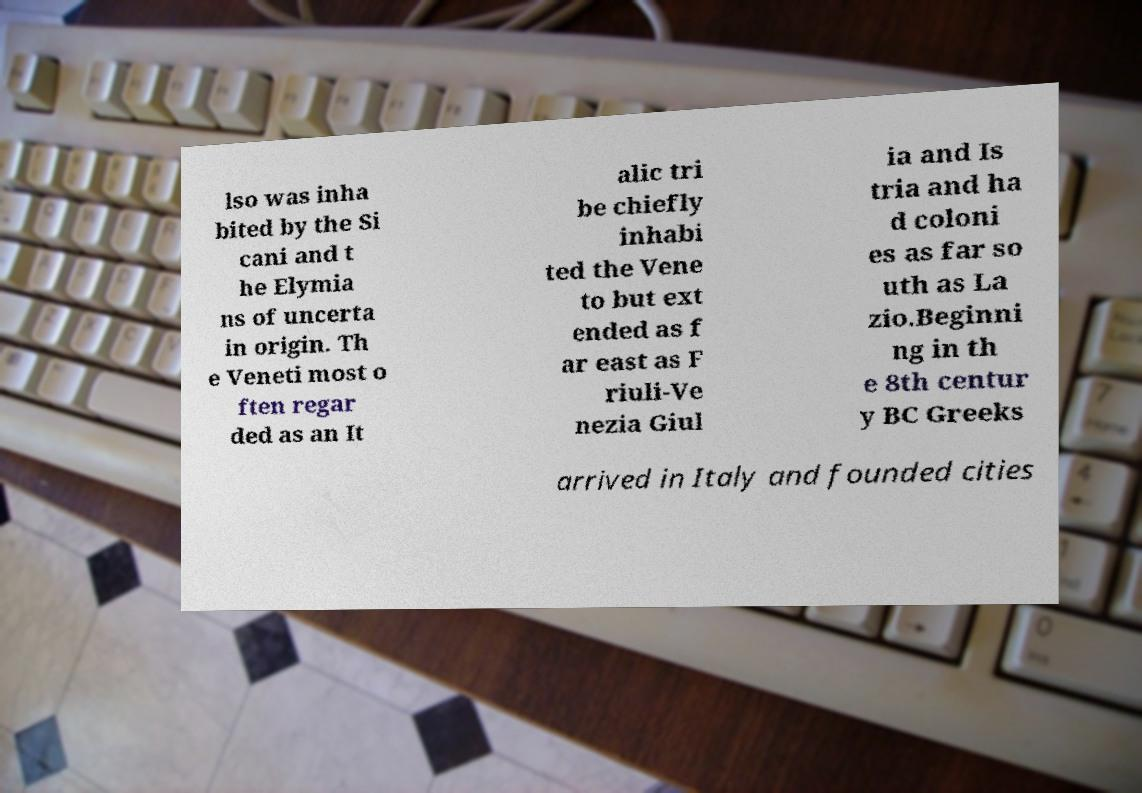Could you extract and type out the text from this image? lso was inha bited by the Si cani and t he Elymia ns of uncerta in origin. Th e Veneti most o ften regar ded as an It alic tri be chiefly inhabi ted the Vene to but ext ended as f ar east as F riuli-Ve nezia Giul ia and Is tria and ha d coloni es as far so uth as La zio.Beginni ng in th e 8th centur y BC Greeks arrived in Italy and founded cities 